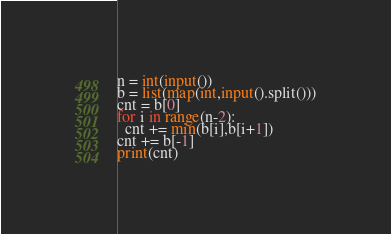Convert code to text. <code><loc_0><loc_0><loc_500><loc_500><_Python_>n = int(input())
b = list(map(int,input().split()))
cnt = b[0]
for i in range(n-2):
  cnt += min(b[i],b[i+1])
cnt += b[-1]
print(cnt)</code> 